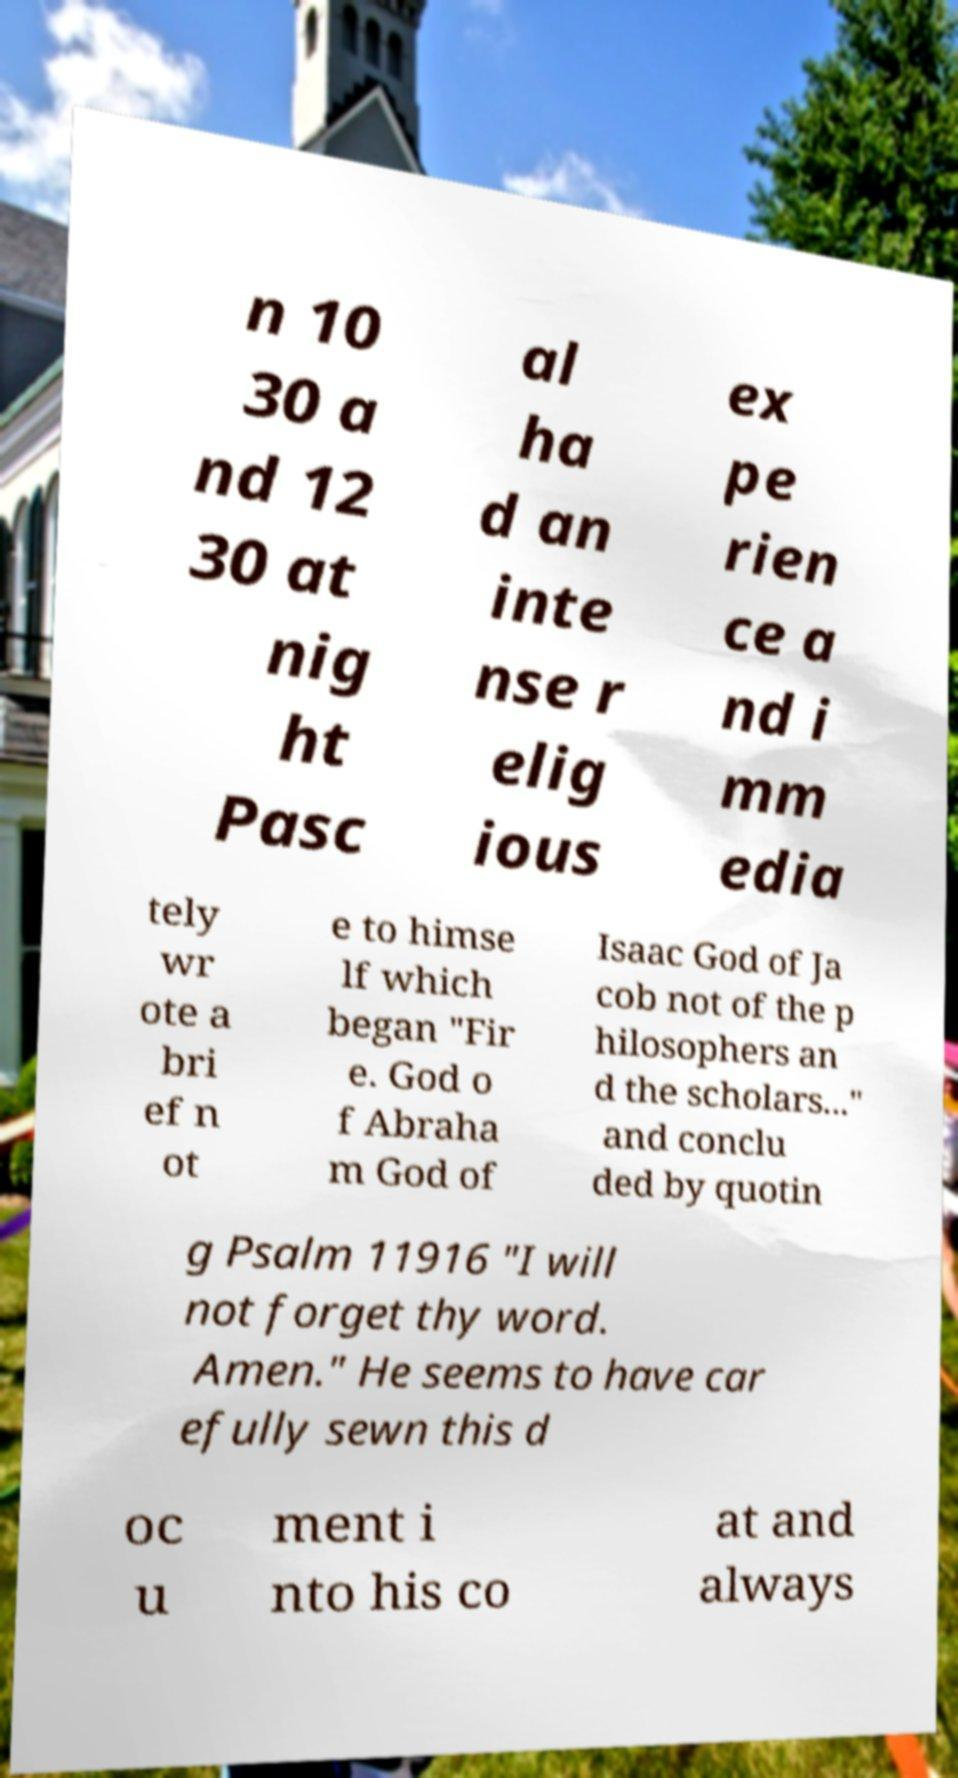Could you assist in decoding the text presented in this image and type it out clearly? n 10 30 a nd 12 30 at nig ht Pasc al ha d an inte nse r elig ious ex pe rien ce a nd i mm edia tely wr ote a bri ef n ot e to himse lf which began "Fir e. God o f Abraha m God of Isaac God of Ja cob not of the p hilosophers an d the scholars..." and conclu ded by quotin g Psalm 11916 "I will not forget thy word. Amen." He seems to have car efully sewn this d oc u ment i nto his co at and always 